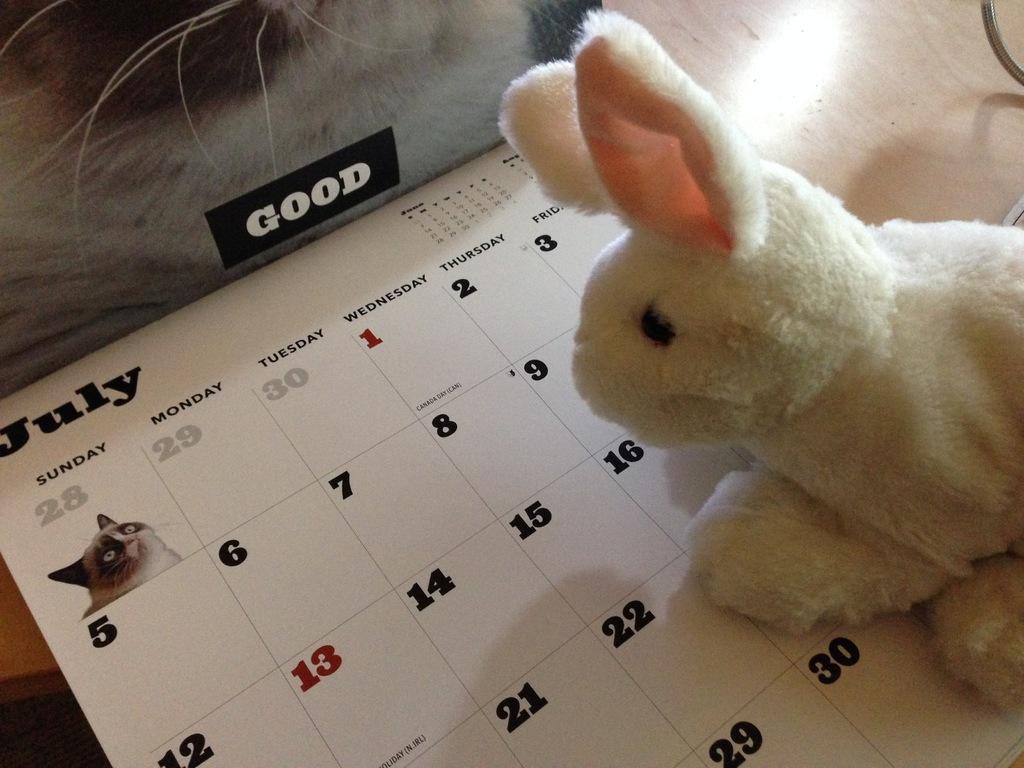Could you give a brief overview of what you see in this image? In this picture i can see a soft toy and a calendar. I can also see some other objects. 